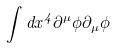<formula> <loc_0><loc_0><loc_500><loc_500>\int d x ^ { 4 } \partial ^ { \mu } \phi \partial _ { \mu } \phi</formula> 